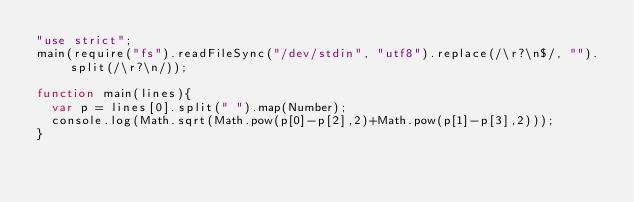Convert code to text. <code><loc_0><loc_0><loc_500><loc_500><_JavaScript_>"use strict";
main(require("fs").readFileSync("/dev/stdin", "utf8").replace(/\r?\n$/, "").split(/\r?\n/));

function main(lines){
	var p = lines[0].split(" ").map(Number);
	console.log(Math.sqrt(Math.pow(p[0]-p[2],2)+Math.pow(p[1]-p[3],2)));
}</code> 